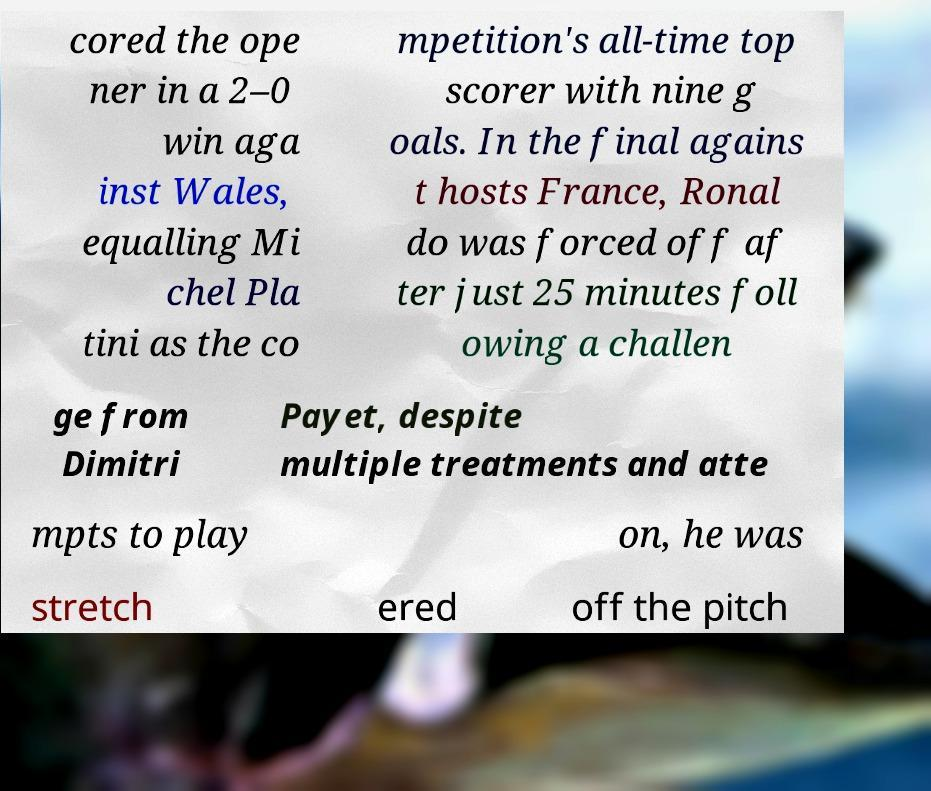Could you extract and type out the text from this image? cored the ope ner in a 2–0 win aga inst Wales, equalling Mi chel Pla tini as the co mpetition's all-time top scorer with nine g oals. In the final agains t hosts France, Ronal do was forced off af ter just 25 minutes foll owing a challen ge from Dimitri Payet, despite multiple treatments and atte mpts to play on, he was stretch ered off the pitch 